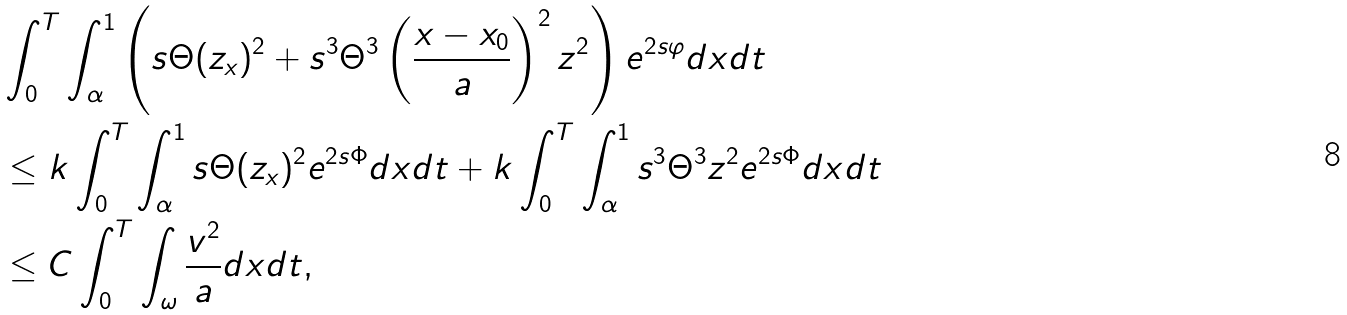<formula> <loc_0><loc_0><loc_500><loc_500>& \int _ { 0 } ^ { T } \int _ { \alpha } ^ { 1 } \left ( s \Theta ( z _ { x } ) ^ { 2 } + s ^ { 3 } \Theta ^ { 3 } \left ( \frac { x - x _ { 0 } } { a } \right ) ^ { 2 } z ^ { 2 } \right ) e ^ { 2 s \varphi } d x d t \\ & \leq k \int _ { 0 } ^ { T } \int _ { \alpha } ^ { 1 } s \Theta ( z _ { x } ) ^ { 2 } e ^ { 2 s \Phi } d x d t + k \int _ { 0 } ^ { T } \int _ { \alpha } ^ { 1 } s ^ { 3 } \Theta ^ { 3 } z ^ { 2 } e ^ { 2 s \Phi } d x d t \\ & \leq C \int _ { 0 } ^ { T } \int _ { \omega } \frac { v ^ { 2 } } { a } d x d t ,</formula> 